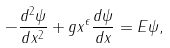Convert formula to latex. <formula><loc_0><loc_0><loc_500><loc_500>- \frac { d ^ { 2 } \psi } { d x ^ { 2 } } + g x ^ { \epsilon } \frac { d \psi } { d x } = E \psi ,</formula> 